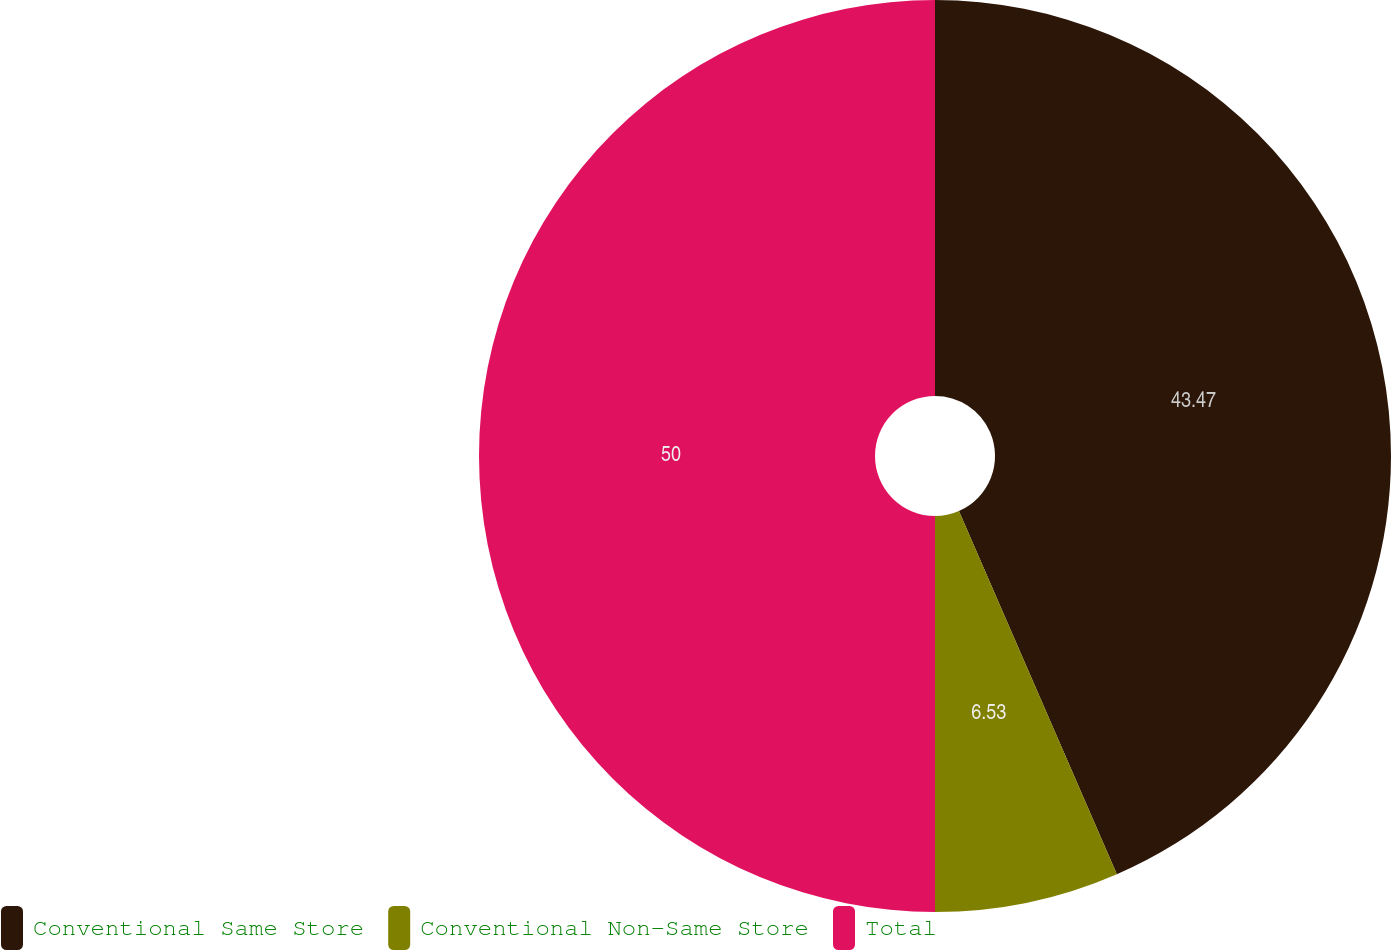Convert chart. <chart><loc_0><loc_0><loc_500><loc_500><pie_chart><fcel>Conventional Same Store<fcel>Conventional Non-Same Store<fcel>Total<nl><fcel>43.47%<fcel>6.53%<fcel>50.0%<nl></chart> 